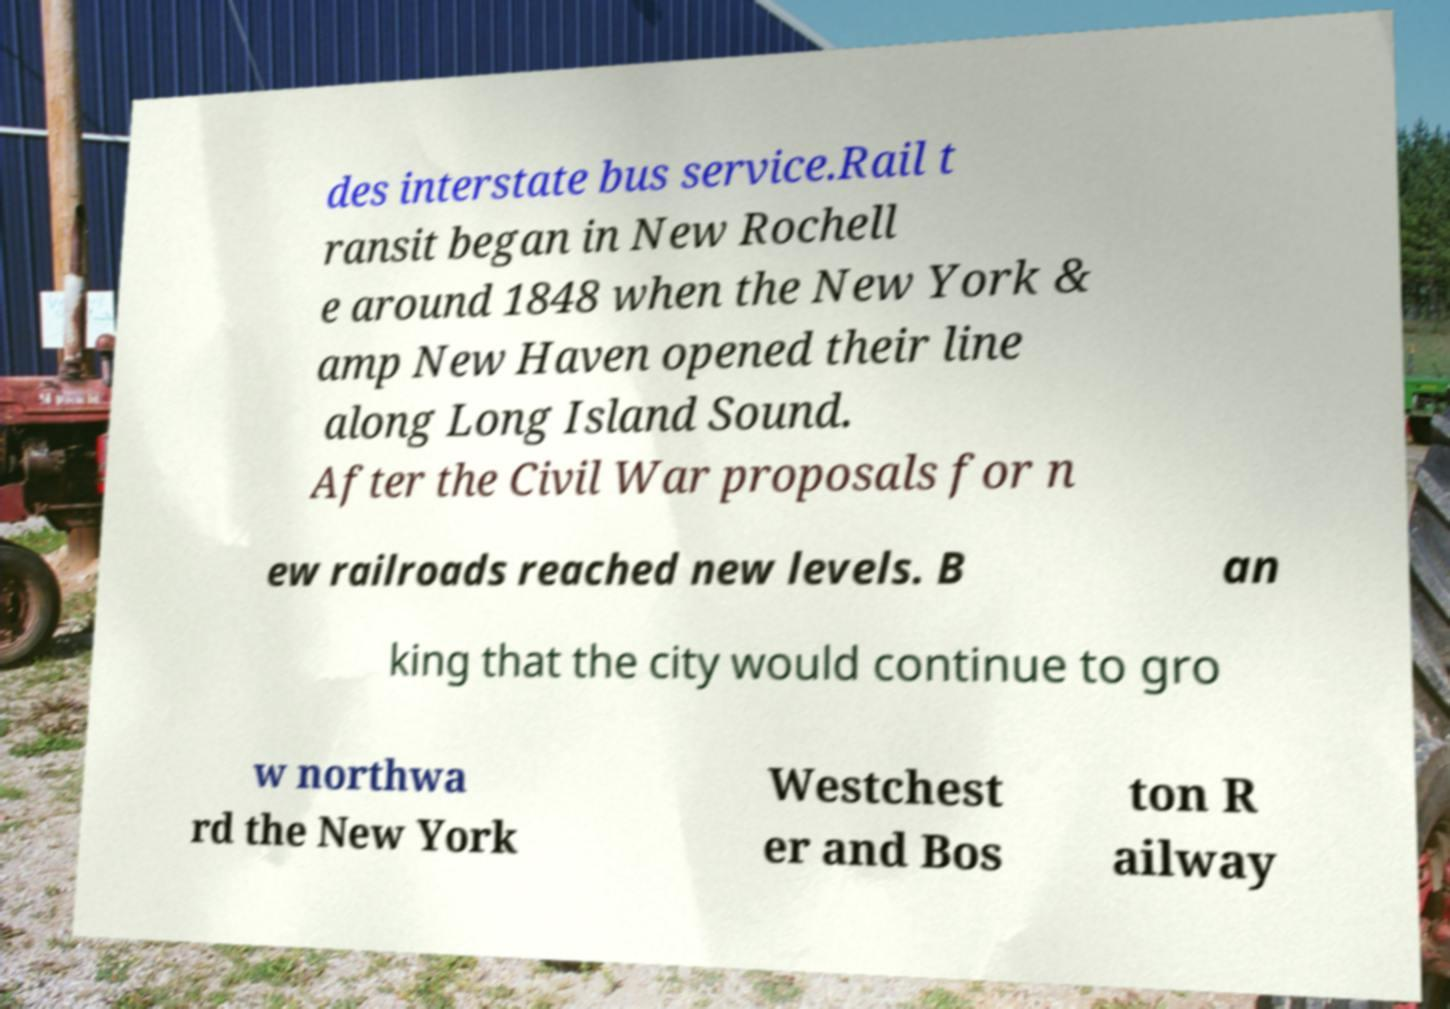I need the written content from this picture converted into text. Can you do that? des interstate bus service.Rail t ransit began in New Rochell e around 1848 when the New York & amp New Haven opened their line along Long Island Sound. After the Civil War proposals for n ew railroads reached new levels. B an king that the city would continue to gro w northwa rd the New York Westchest er and Bos ton R ailway 